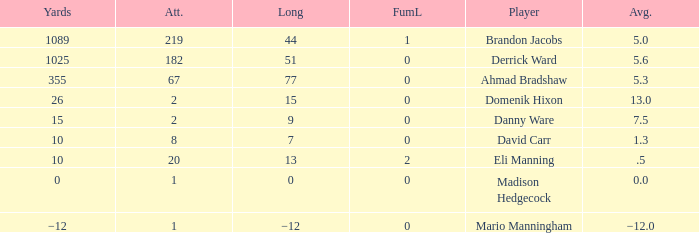What is Domenik Hixon's average rush? 13.0. 